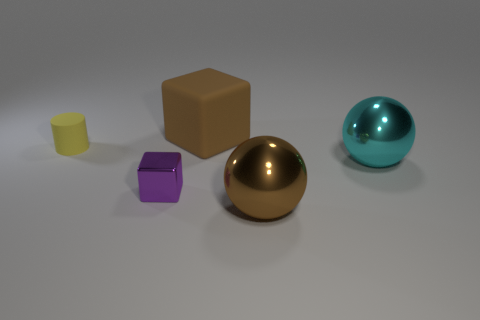There is a sphere that is left of the cyan shiny object; are there any brown cubes that are right of it?
Provide a short and direct response. No. Are there fewer big brown metal balls right of the big brown ball than large brown matte objects that are in front of the rubber cube?
Make the answer very short. No. There is a shiny thing on the left side of the brown thing that is behind the block in front of the large brown cube; how big is it?
Offer a terse response. Small. There is a metal thing in front of the purple metallic object; is it the same size as the purple thing?
Give a very brief answer. No. How many other objects are there of the same material as the purple block?
Offer a terse response. 2. Is the number of shiny balls greater than the number of small shiny things?
Your answer should be very brief. Yes. What is the material of the ball that is behind the big brown object that is to the right of the rubber object right of the cylinder?
Your response must be concise. Metal. Does the small metallic cube have the same color as the small matte cylinder?
Your response must be concise. No. Is there a rubber cylinder that has the same color as the small metal cube?
Provide a succinct answer. No. There is a purple object that is the same size as the matte cylinder; what shape is it?
Ensure brevity in your answer.  Cube. 